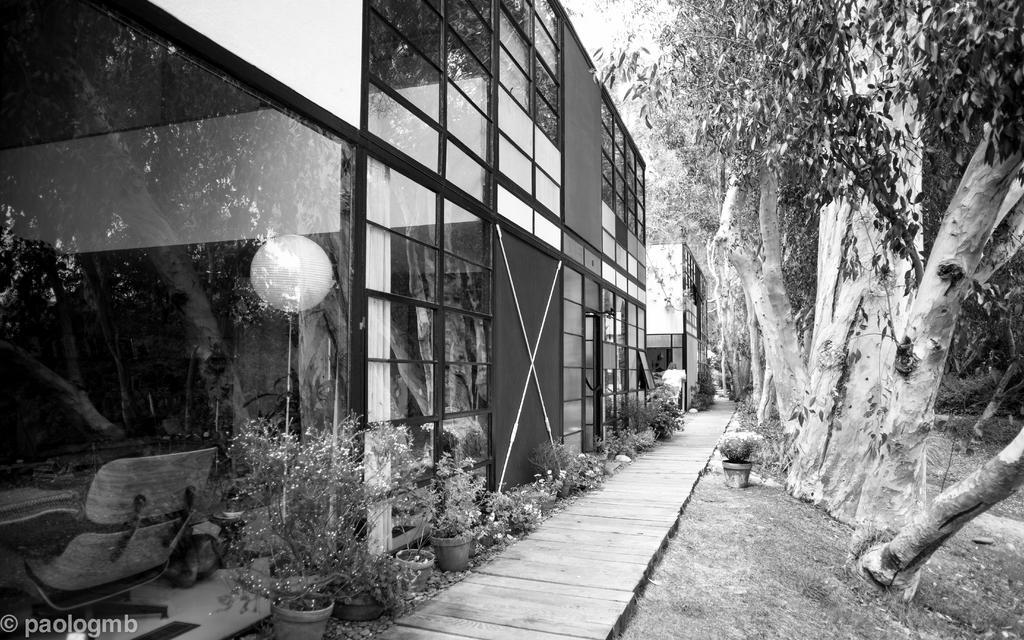Describe this image in one or two sentences. This image consists of a building. At the bottom, there are plants. To the right, there are trees. In the middle, there is a path. 